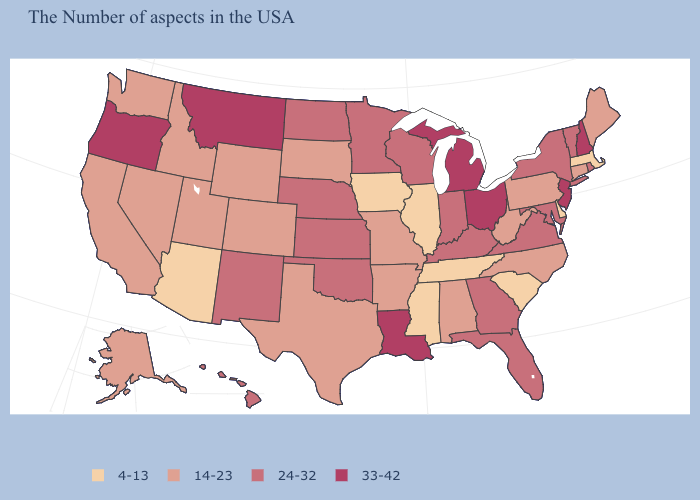Which states have the lowest value in the USA?
Quick response, please. Massachusetts, Delaware, South Carolina, Tennessee, Illinois, Mississippi, Iowa, Arizona. Does Ohio have the same value as Montana?
Keep it brief. Yes. Name the states that have a value in the range 4-13?
Quick response, please. Massachusetts, Delaware, South Carolina, Tennessee, Illinois, Mississippi, Iowa, Arizona. Which states hav the highest value in the West?
Answer briefly. Montana, Oregon. What is the value of South Carolina?
Keep it brief. 4-13. How many symbols are there in the legend?
Keep it brief. 4. What is the value of South Dakota?
Answer briefly. 14-23. Which states hav the highest value in the Northeast?
Answer briefly. New Hampshire, New Jersey. What is the value of Tennessee?
Answer briefly. 4-13. Does the map have missing data?
Write a very short answer. No. Among the states that border Missouri , which have the lowest value?
Short answer required. Tennessee, Illinois, Iowa. Which states hav the highest value in the West?
Short answer required. Montana, Oregon. What is the lowest value in states that border Connecticut?
Quick response, please. 4-13. What is the highest value in the Northeast ?
Write a very short answer. 33-42. Name the states that have a value in the range 14-23?
Short answer required. Maine, Connecticut, Pennsylvania, North Carolina, West Virginia, Alabama, Missouri, Arkansas, Texas, South Dakota, Wyoming, Colorado, Utah, Idaho, Nevada, California, Washington, Alaska. 